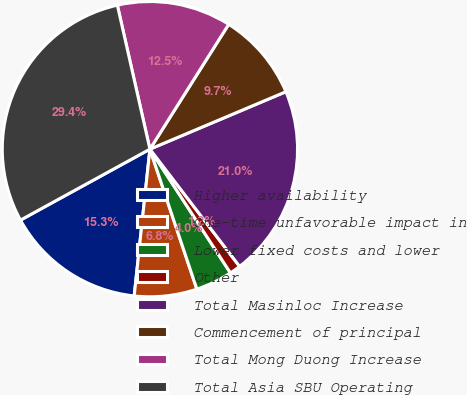Convert chart to OTSL. <chart><loc_0><loc_0><loc_500><loc_500><pie_chart><fcel>Higher availability<fcel>One-time unfavorable impact in<fcel>Lower fixed costs and lower<fcel>Other<fcel>Total Masinloc Increase<fcel>Commencement of principal<fcel>Total Mong Duong Increase<fcel>Total Asia SBU Operating<nl><fcel>15.32%<fcel>6.85%<fcel>4.03%<fcel>1.21%<fcel>20.97%<fcel>9.68%<fcel>12.5%<fcel>29.44%<nl></chart> 